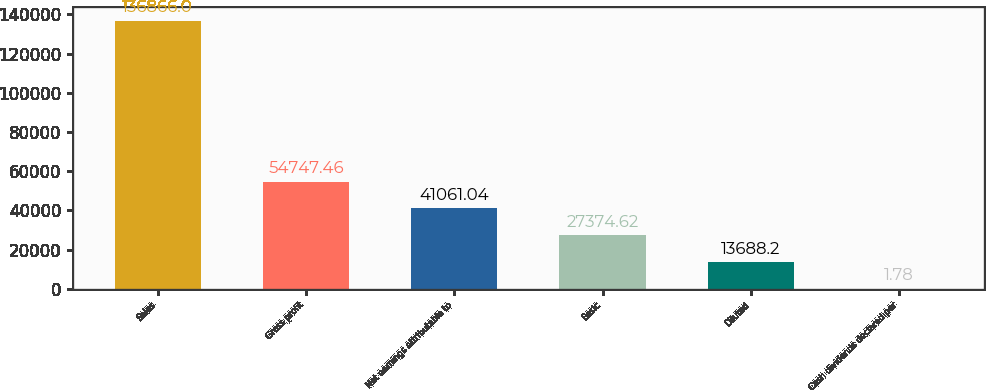Convert chart. <chart><loc_0><loc_0><loc_500><loc_500><bar_chart><fcel>Sales<fcel>Gross profit<fcel>Net earnings attributable to<fcel>Basic<fcel>Diluted<fcel>Cash dividends declared per<nl><fcel>136866<fcel>54747.5<fcel>41061<fcel>27374.6<fcel>13688.2<fcel>1.78<nl></chart> 